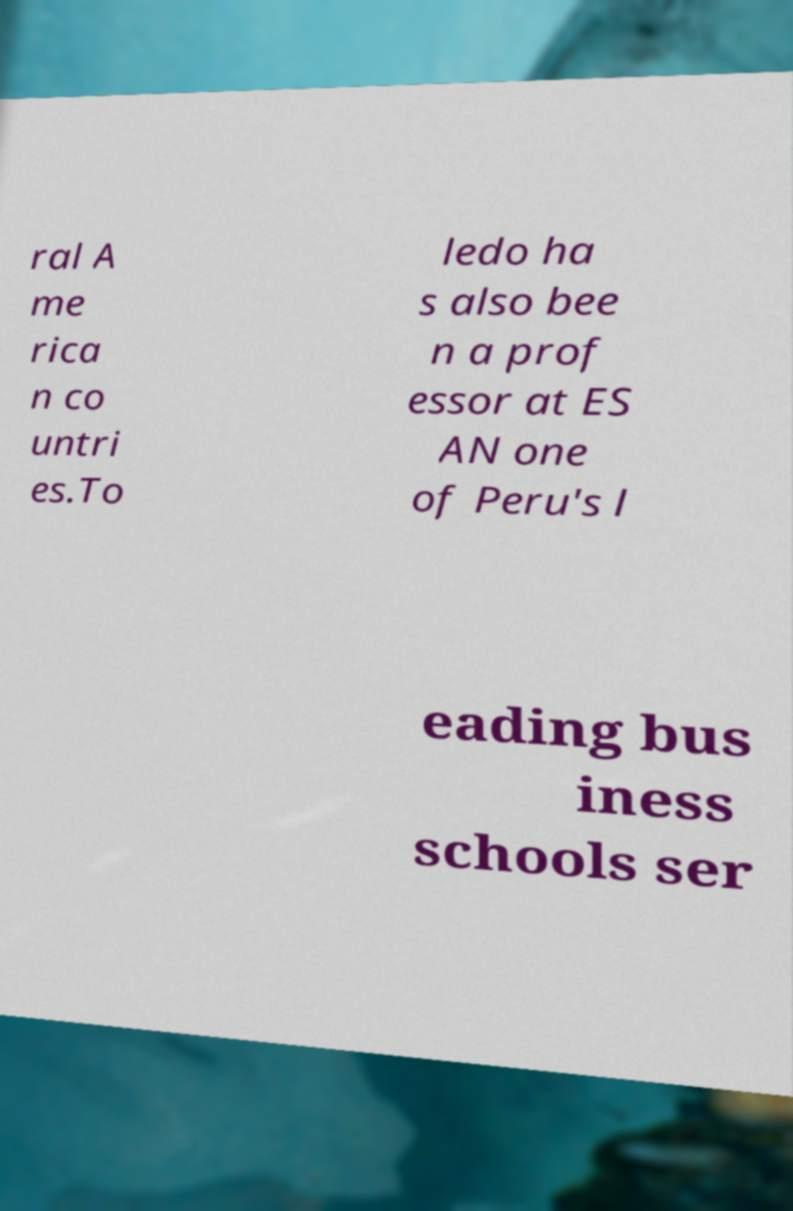Can you read and provide the text displayed in the image?This photo seems to have some interesting text. Can you extract and type it out for me? ral A me rica n co untri es.To ledo ha s also bee n a prof essor at ES AN one of Peru's l eading bus iness schools ser 